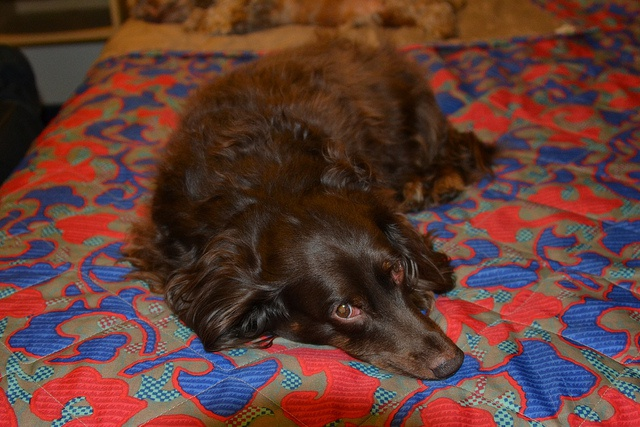Describe the objects in this image and their specific colors. I can see bed in black, maroon, and brown tones and dog in black, maroon, and gray tones in this image. 